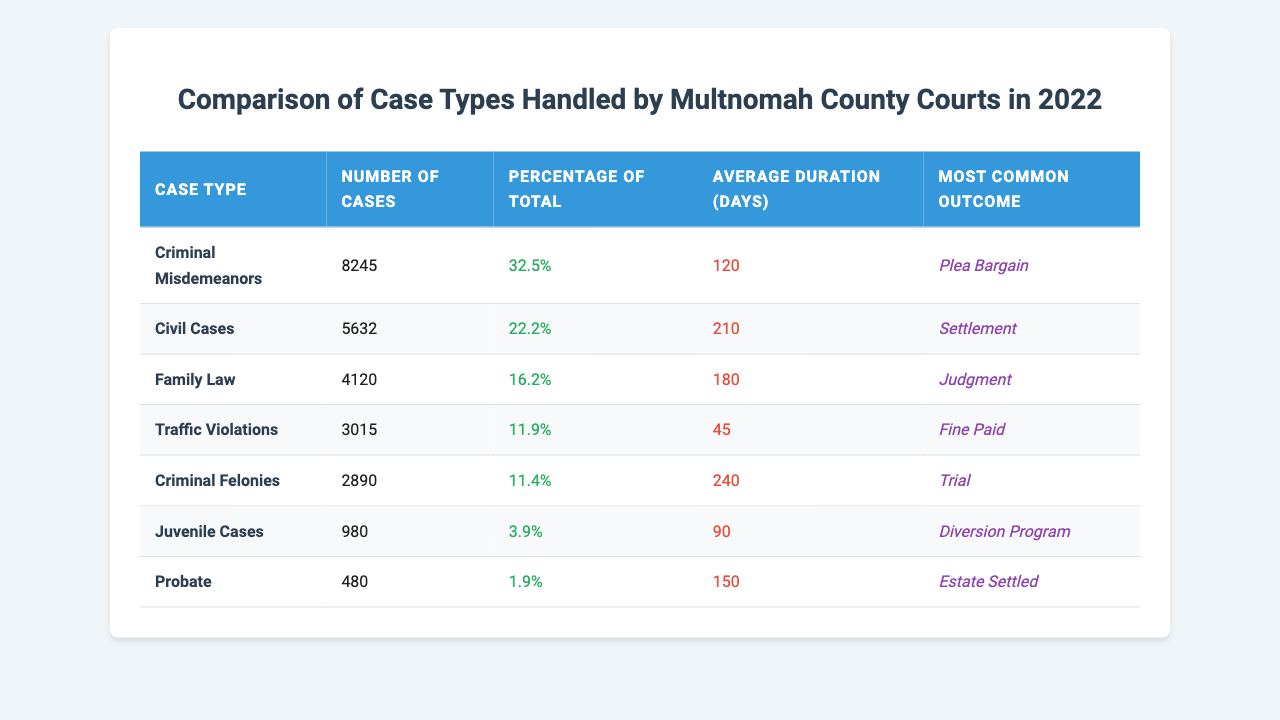What is the case type with the highest number of cases? To find the case type with the highest number of cases, look at the "Number of Cases" column and identify the maximum value, which is 8245 corresponding to "Criminal Misdemeanors."
Answer: Criminal Misdemeanors What percentage of total cases do Family Law cases represent? The "Percentage of Total" for Family Law cases is provided directly in the table as "16.2%."
Answer: 16.2% What is the average duration of cases for Traffic Violations? The average duration for Traffic Violations is shown in the "Average Duration (Days)" column as 45 days.
Answer: 45 days How many more Civil Cases were handled than Juvenile Cases? The number of Civil Cases is 5632 and Juvenile Cases is 980. The difference is 5632 - 980 = 4652.
Answer: 4652 What is the most common outcome for Criminal Felonies? The table indicates the most common outcome for Criminal Felonies is "Trial."
Answer: Trial Which case type had the longest average duration, and what is that duration? Looking at the "Average Duration (Days)" column, Criminal Felonies has the longest duration at 240 days.
Answer: Criminal Felonies, 240 days What percentage of cases do Criminal cases (both Misdemeanors and Felonies) account for? Combine the percentages for Criminal Misdemeanors (32.5%) and Criminal Felonies (11.4%), which total 32.5% + 11.4% = 43.9%.
Answer: 43.9% Is the average duration of Family Law cases longer than that of Traffic Violations? Family Law average duration is 180 days, while Traffic Violations is 45 days. Since 180 is greater than 45, the statement is true.
Answer: Yes What is the total number of cases represented in the table? To find the total, add up all the cases: 8245 + 5632 + 4120 + 3015 + 2890 + 980 + 480 = 18862.
Answer: 18862 Which case type has the smallest share of total cases and what is that share? The table shows "Probate" as the case type with the smallest number of cases (480) and its percentage is 1.9%.
Answer: Probate, 1.9% 